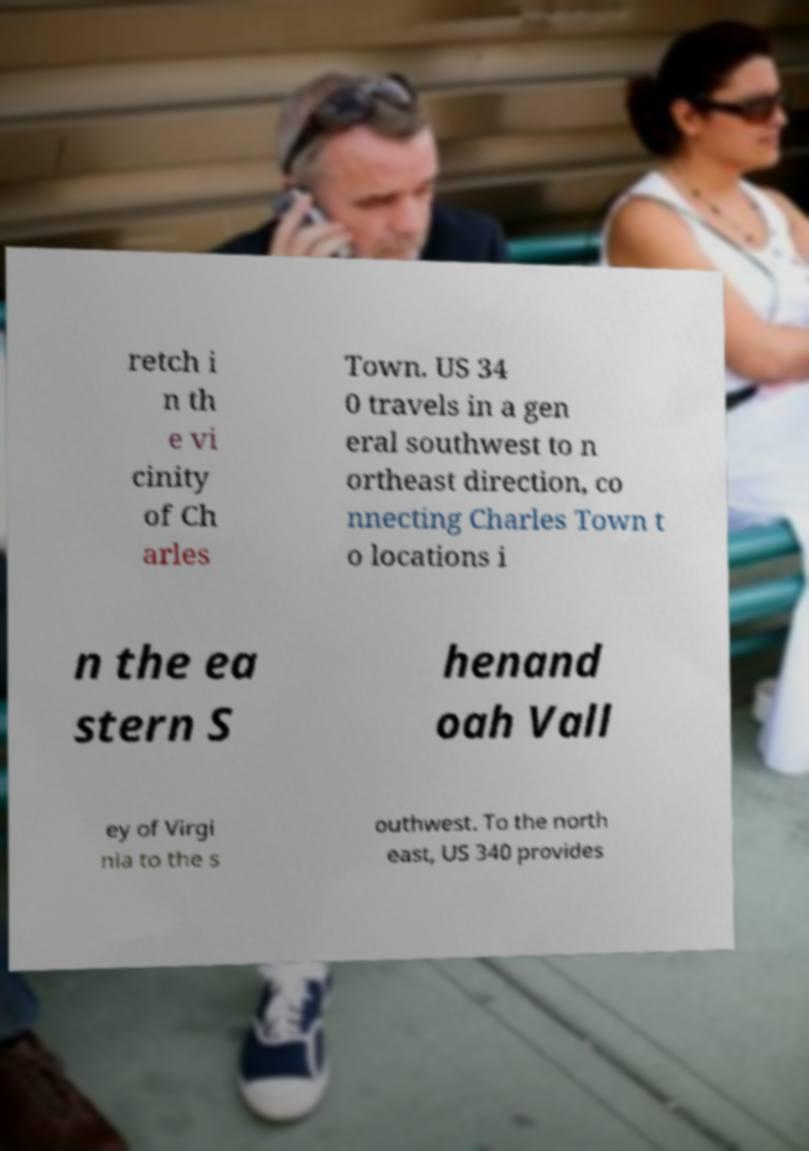I need the written content from this picture converted into text. Can you do that? retch i n th e vi cinity of Ch arles Town. US 34 0 travels in a gen eral southwest to n ortheast direction, co nnecting Charles Town t o locations i n the ea stern S henand oah Vall ey of Virgi nia to the s outhwest. To the north east, US 340 provides 